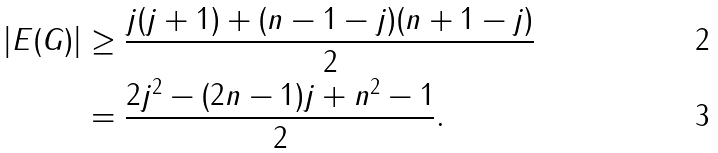<formula> <loc_0><loc_0><loc_500><loc_500>| E ( G ) | & \geq \frac { j ( j + 1 ) + ( n - 1 - j ) ( n + 1 - j ) } { 2 } \\ & = \frac { 2 j ^ { 2 } - ( 2 n - 1 ) j + n ^ { 2 } - 1 } { 2 } .</formula> 